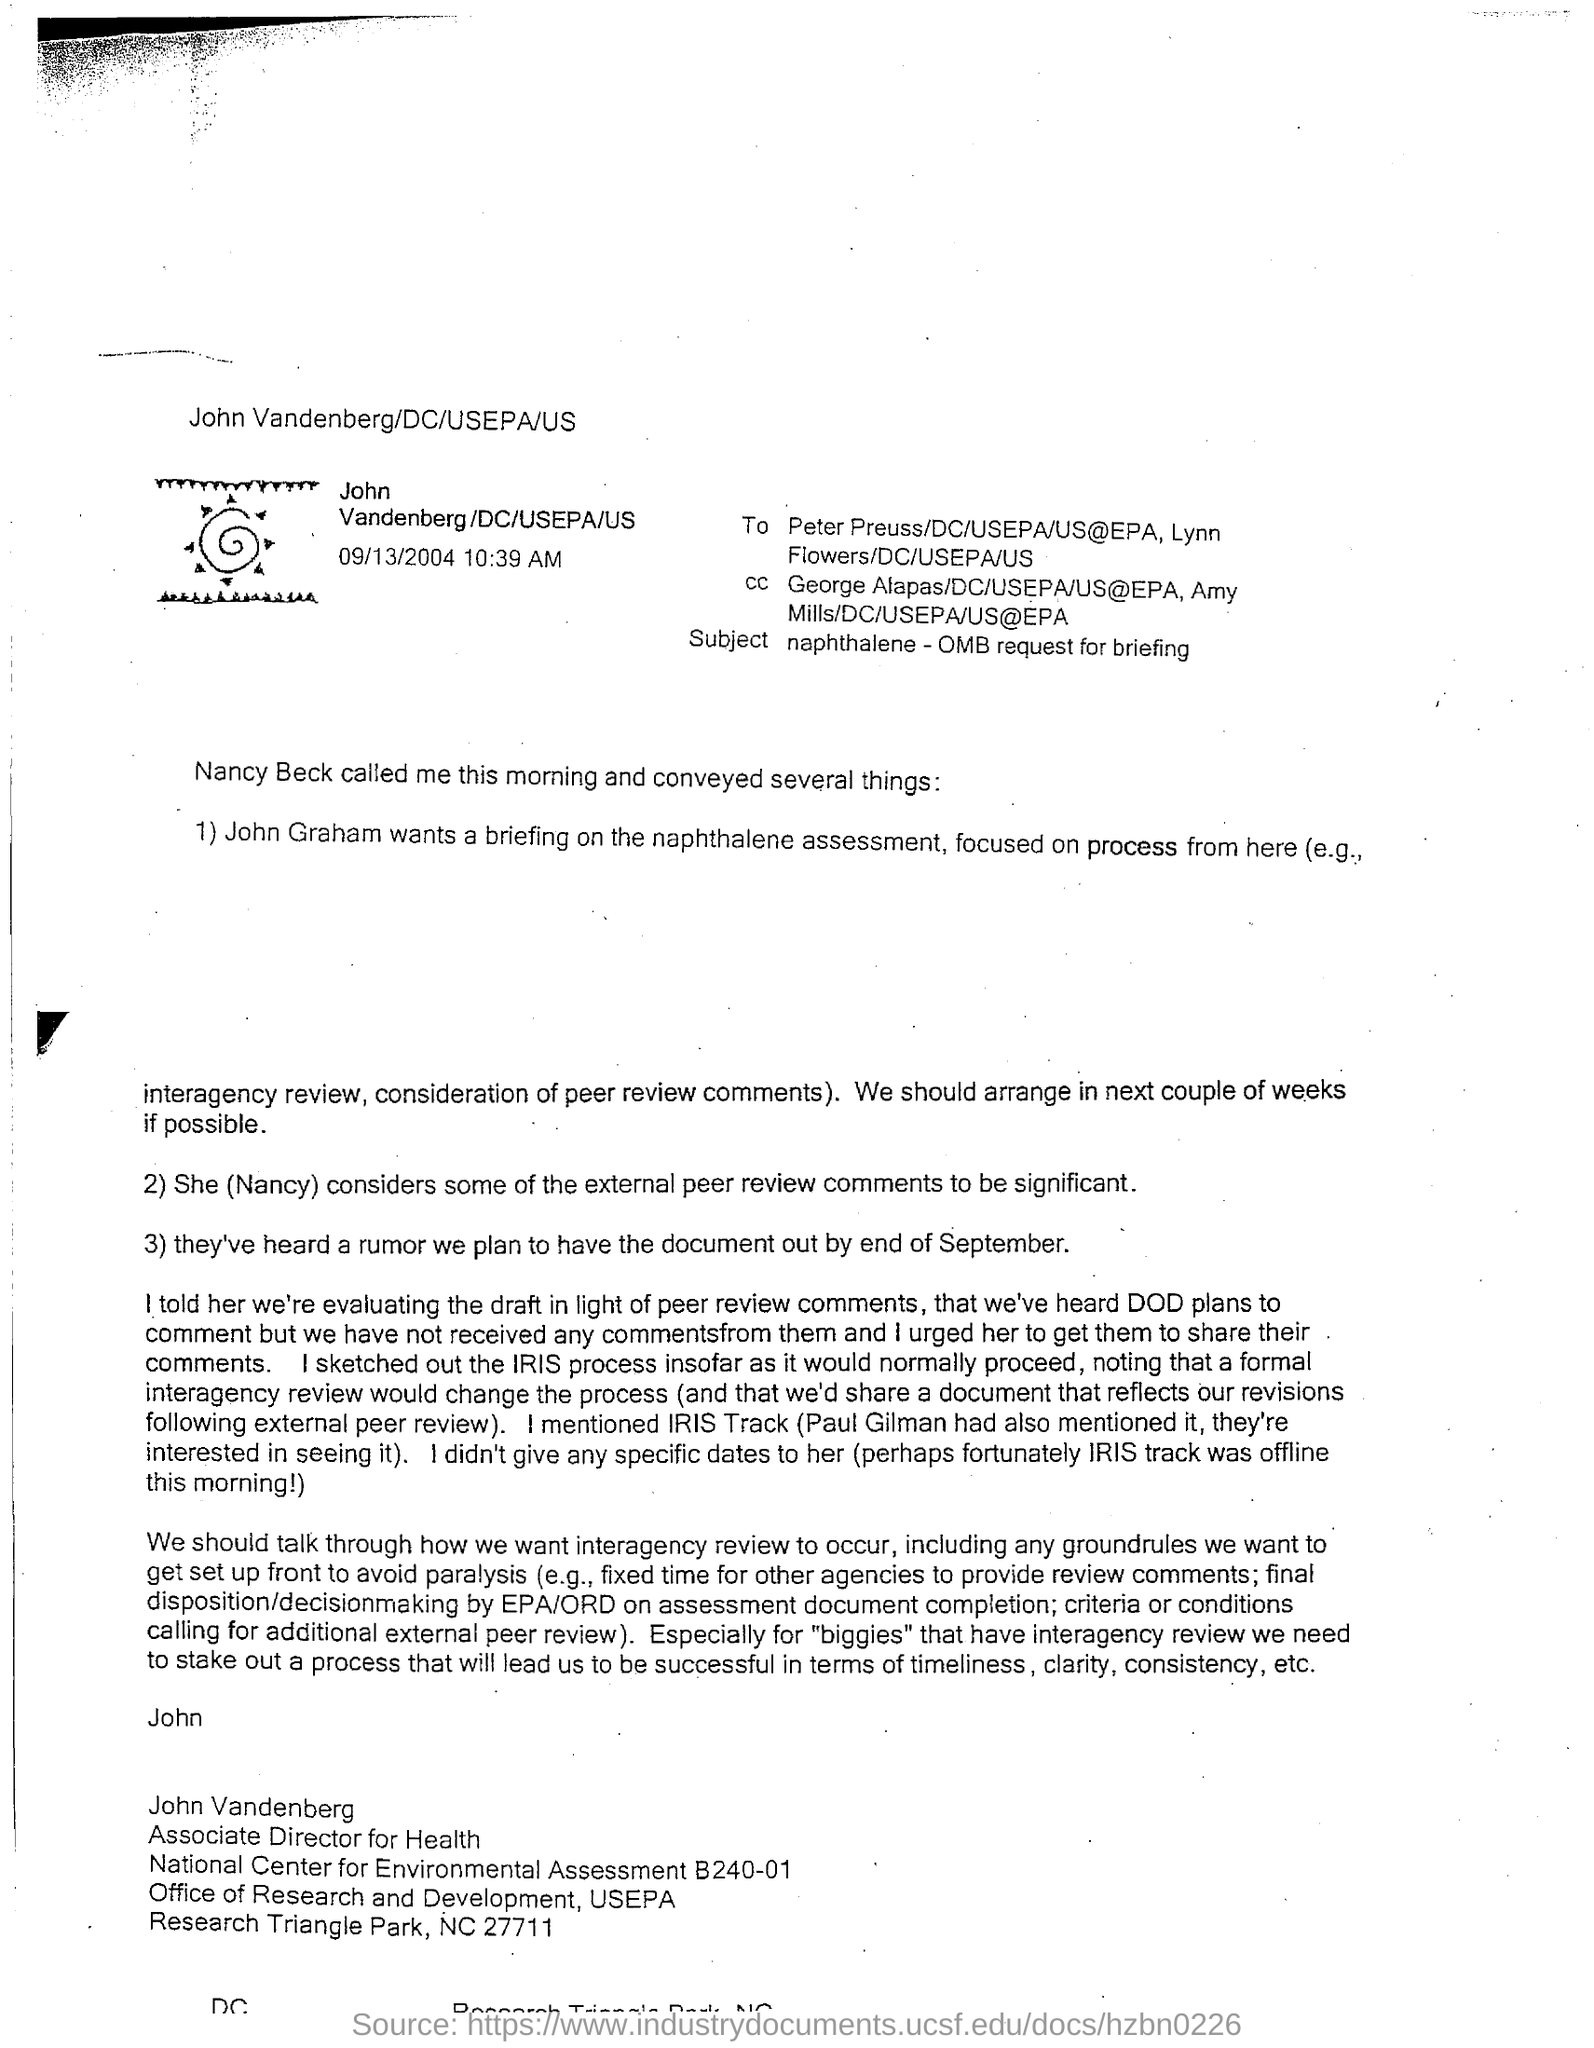Who is the sender of this email?
Provide a short and direct response. John Vandenberg. What is the designation of John Vandenberg?
Make the answer very short. Associate Director for Health. What is the sent date and time of the email?
Your response must be concise. 09/13/2004 10:39 AM. What is the subject mentioned in this email?
Your answer should be compact. Naphthalene - omb request for briefing. 